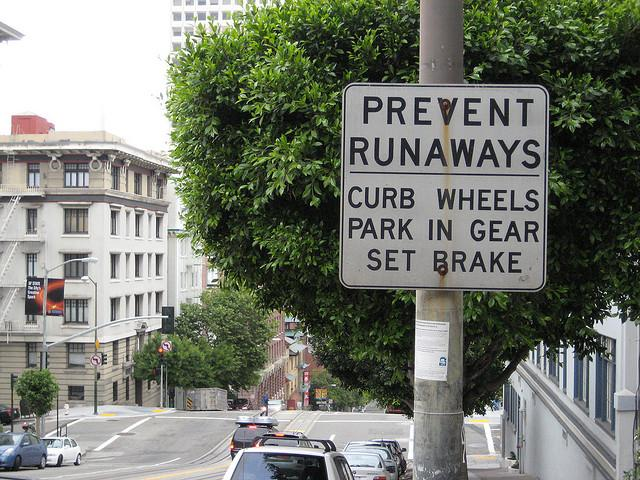What type vehicle does this sign refer to? car 